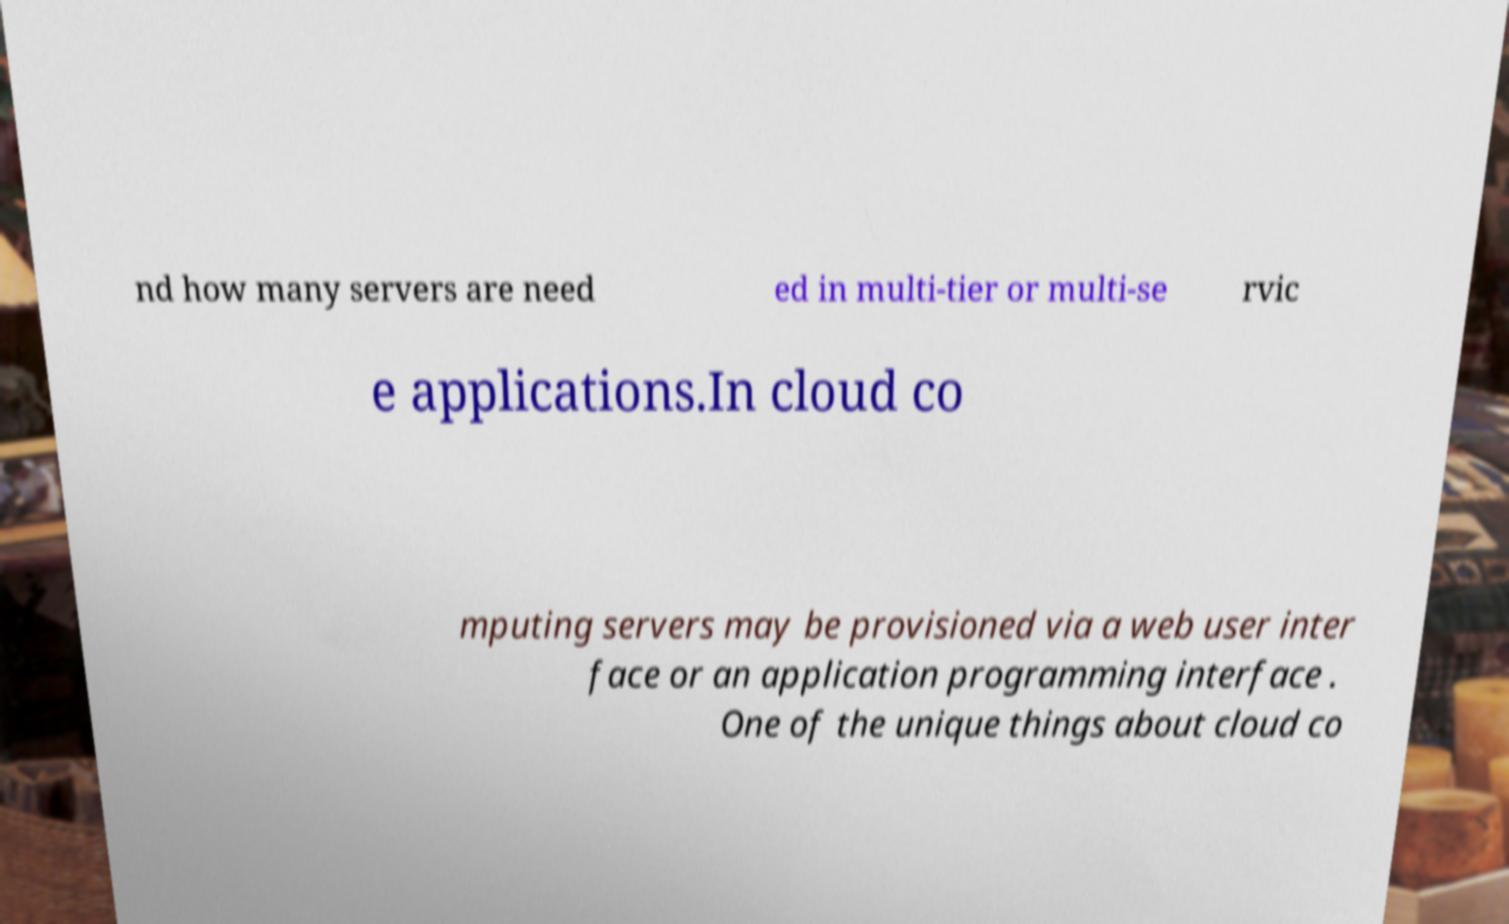For documentation purposes, I need the text within this image transcribed. Could you provide that? nd how many servers are need ed in multi-tier or multi-se rvic e applications.In cloud co mputing servers may be provisioned via a web user inter face or an application programming interface . One of the unique things about cloud co 